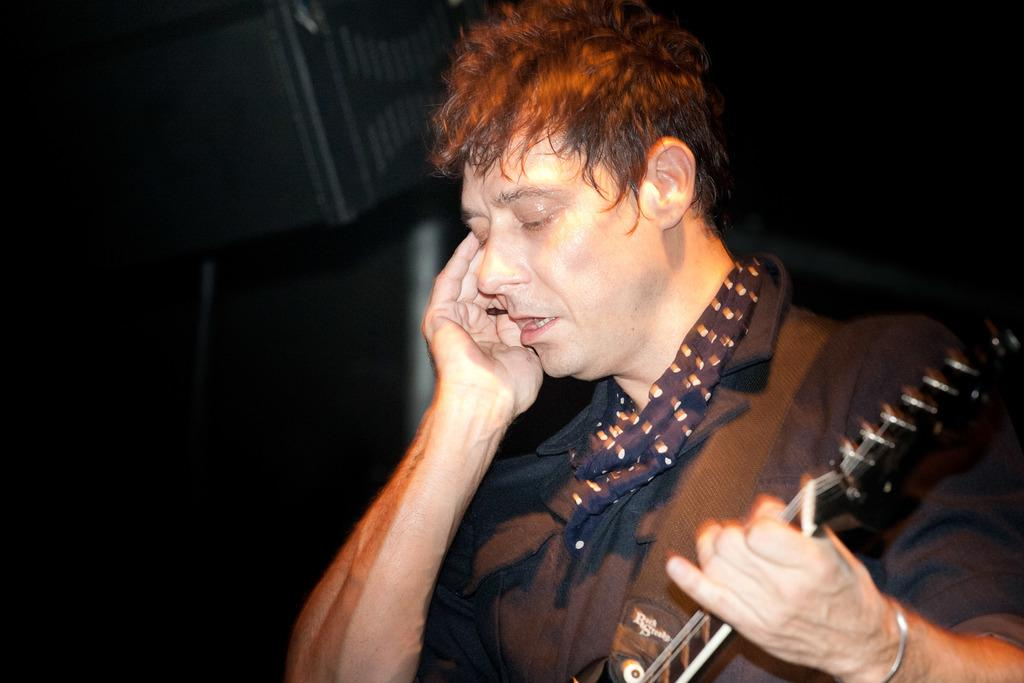What is the main subject of the image? The main subject of the image is a man. What is the man holding in the image? The man is holding a guitar in the image. What type of needle is the man using to play the guitar in the image? There is no needle present in the image, and the man is not using a needle to play the guitar. 